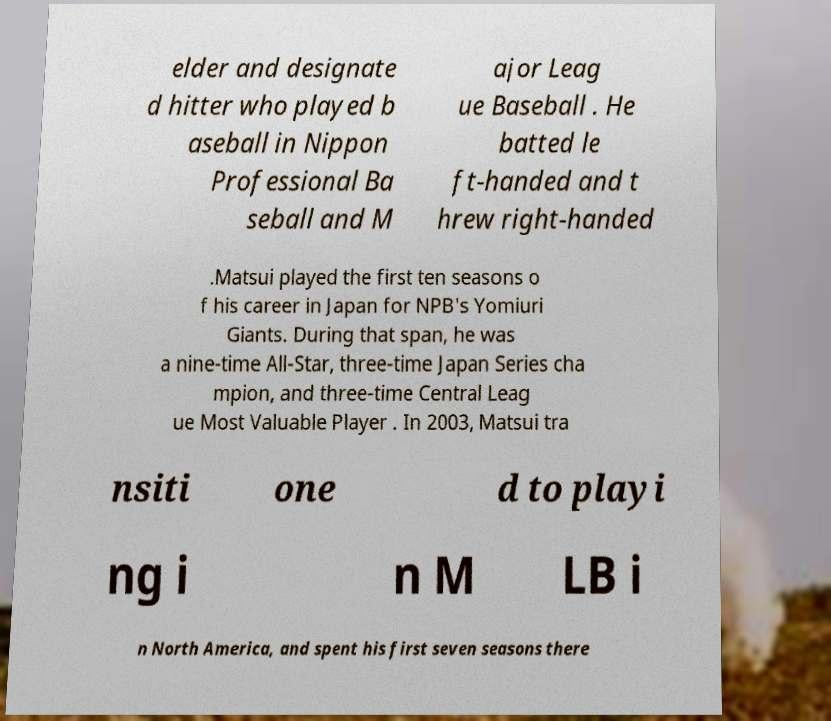Could you extract and type out the text from this image? elder and designate d hitter who played b aseball in Nippon Professional Ba seball and M ajor Leag ue Baseball . He batted le ft-handed and t hrew right-handed .Matsui played the first ten seasons o f his career in Japan for NPB's Yomiuri Giants. During that span, he was a nine-time All-Star, three-time Japan Series cha mpion, and three-time Central Leag ue Most Valuable Player . In 2003, Matsui tra nsiti one d to playi ng i n M LB i n North America, and spent his first seven seasons there 